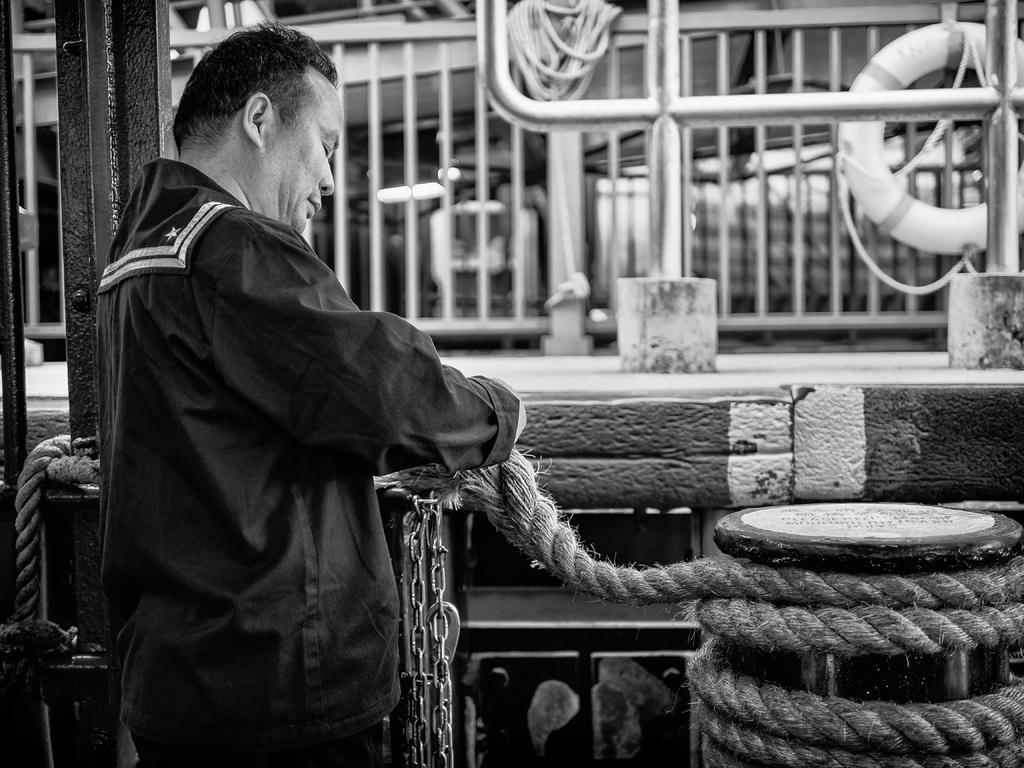What is the main subject of the image? There is a person in the image. What is the person holding in his hand? The person is holding a rope in his hand. What is in front of the person? There is a chain in front of the person. What can be seen in the background of the image? There is railing in the background of the image. How is the image presented in terms of color? The image is black and white. What type of fear can be seen on the person's face in the image? There is no indication of fear on the person's face in the image. Can you tell me how many mothers are present in the image? There is no mother present in the image. What type of owl can be seen perched on the railing in the background? There is no owl present in the image. 